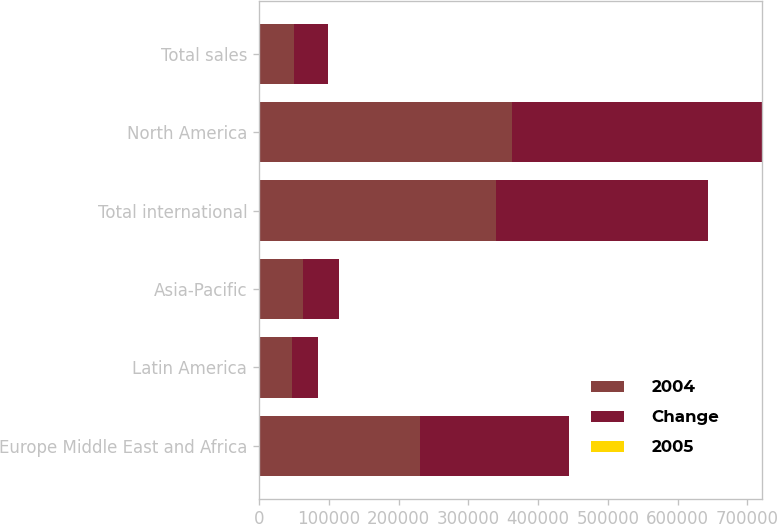Convert chart. <chart><loc_0><loc_0><loc_500><loc_500><stacked_bar_chart><ecel><fcel>Europe Middle East and Africa<fcel>Latin America<fcel>Asia-Pacific<fcel>Total international<fcel>North America<fcel>Total sales<nl><fcel>2004<fcel>230365<fcel>46878<fcel>62974<fcel>340217<fcel>362054<fcel>49590<nl><fcel>Change<fcel>213559<fcel>38119<fcel>52302<fcel>303980<fcel>359074<fcel>49590<nl><fcel>2005<fcel>7.9<fcel>23<fcel>20.4<fcel>11.9<fcel>0.8<fcel>5.9<nl></chart> 